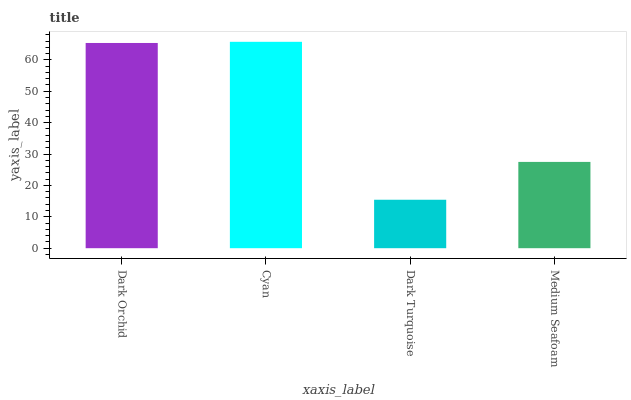Is Cyan the minimum?
Answer yes or no. No. Is Dark Turquoise the maximum?
Answer yes or no. No. Is Cyan greater than Dark Turquoise?
Answer yes or no. Yes. Is Dark Turquoise less than Cyan?
Answer yes or no. Yes. Is Dark Turquoise greater than Cyan?
Answer yes or no. No. Is Cyan less than Dark Turquoise?
Answer yes or no. No. Is Dark Orchid the high median?
Answer yes or no. Yes. Is Medium Seafoam the low median?
Answer yes or no. Yes. Is Dark Turquoise the high median?
Answer yes or no. No. Is Cyan the low median?
Answer yes or no. No. 